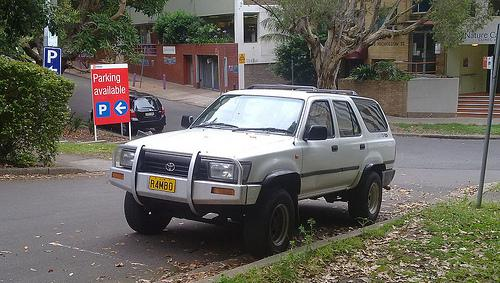Question: what does the red sign read?
Choices:
A. Parking Available.
B. No parking.
C. Stop.
D. Caution.
Answer with the letter. Answer: A Question: what vehicle can be seen in the foreground?
Choices:
A. Truck.
B. Car.
C. An SUV.
D. Pickup.
Answer with the letter. Answer: C Question: what color is the color of the front license plate on the white SUV?
Choices:
A. Yellow.
B. Red.
C. Green.
D. Purple.
Answer with the letter. Answer: A Question: how many vehicles are visible?
Choices:
A. Three.
B. Four.
C. Five.
D. Two.
Answer with the letter. Answer: D Question: who is the maker of the vehicle in the photo?
Choices:
A. Honda.
B. Infiniti.
C. Scion.
D. Toyota.
Answer with the letter. Answer: D Question: where was the photo taken?
Choices:
A. Outside.
B. A street.
C. At beach.
D. At church.
Answer with the letter. Answer: B Question: when was the photo taken?
Choices:
A. Morning.
B. Noon.
C. Daytime.
D. Evening.
Answer with the letter. Answer: C 